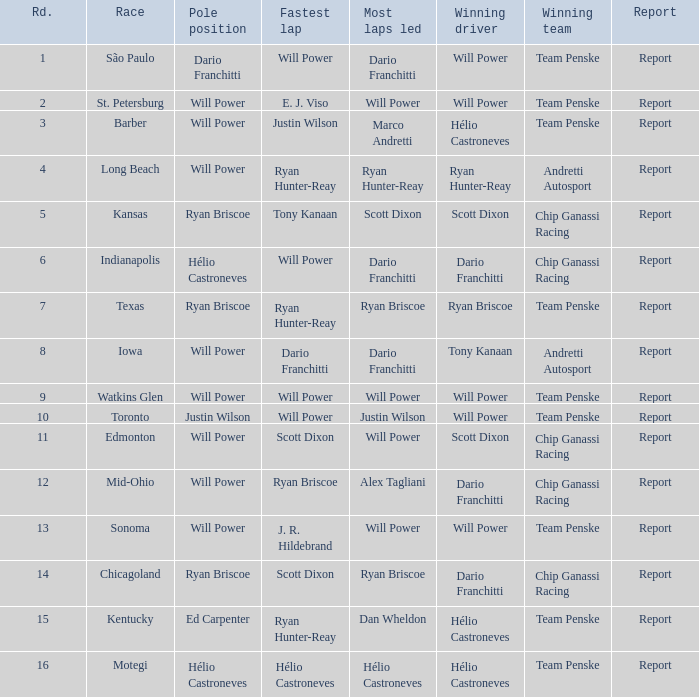In what position did the winning driver finish at Chicagoland? 1.0. 